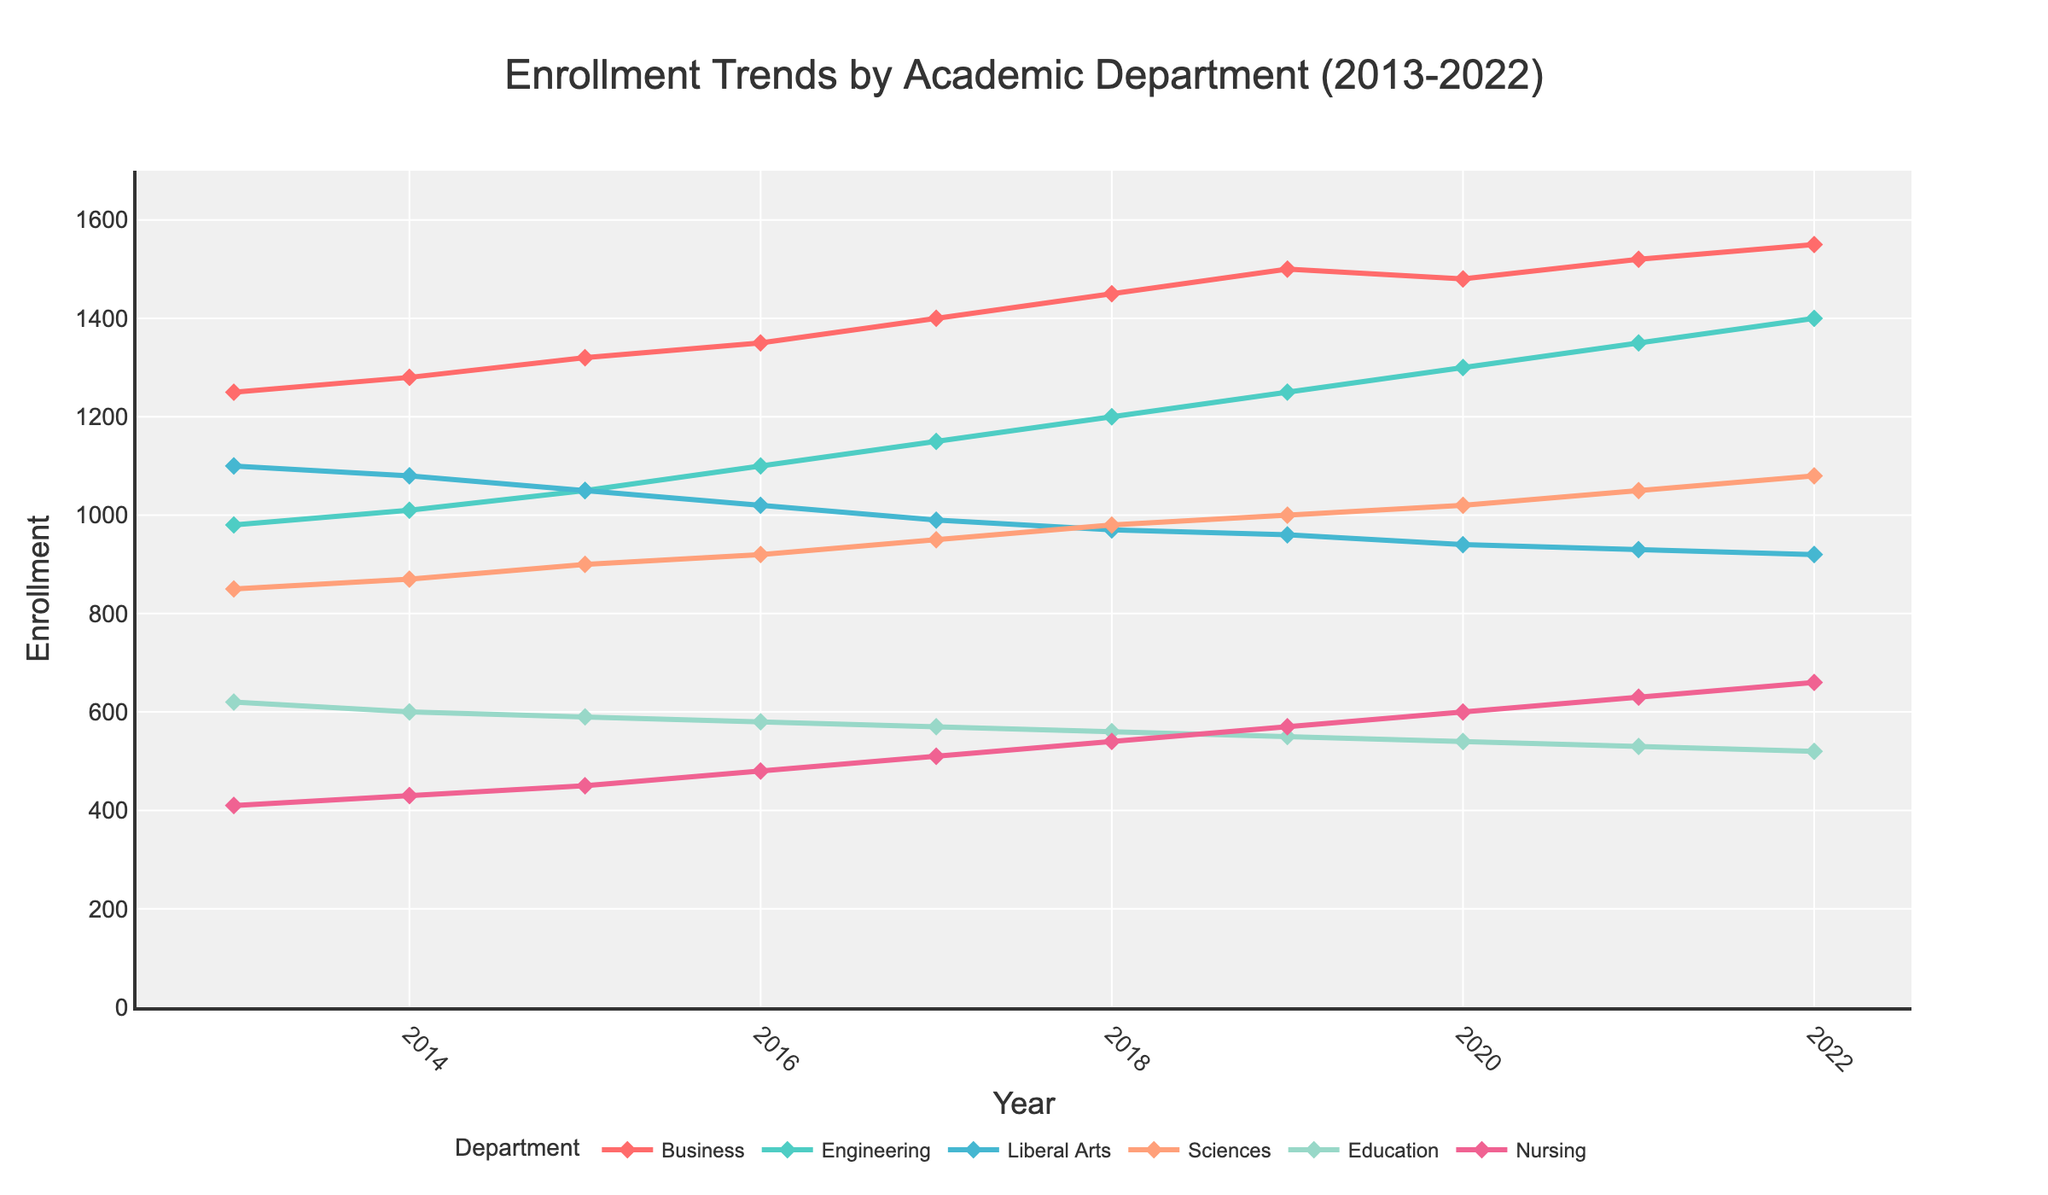Which department had the highest enrollment in 2022? To determine this, we look at the endpoints of all line plots for 2022. The Business department reaches the highest value on the y-axis.
Answer: Business How many total students were enrolled in 2017 across all departments? Sum the enrollment numbers of all departments for the year 2017: 1400 (Business) + 1150 (Engineering) + 990 (Liberal Arts) + 950 (Sciences) + 570 (Education) + 510 (Nursing). The total is 5570.
Answer: 5570 Which department experienced the greatest enrollment increase between 2013 and 2022? Calculate the difference in enrollment from 2013 to 2022 for each department and identify the largest difference. Business went from 1250 to 1550 (an increase of 300), the highest among all departments.
Answer: Business In what year did the Engineering department surpass 1000 enrollments? Look for the first year where the Engineering line plot crosses above 1000. That occurs in 2014.
Answer: 2014 What was the average enrollment for the Nursing department over the given period? Calculate the average of the Nursing enrollments from 2013 to 2022. Summing up the values: 410 + 430 + 450 + 480 + 510 + 540 + 570 + 600 + 630 + 660 = 5280. Dividing by 10 years gives an average of 528.
Answer: 528 Which department's enrollment decreased between 2019 and 2020? Compare the enrollment figures of each department from 2019 to 2020. The Business department shows a decrease from 1500 to 1480.
Answer: Business In 2016, how did the enrollment in Liberal Arts compare to that in Education? Look at the 2016 data points for both departments: Liberal Arts had 1020 and Education had 580. By comparing the two, Liberal Arts had a higher enrollment.
Answer: Liberal Arts What was the overall trend for the Sciences department from 2013 to 2022? Assess the plot for the Sciences department over the time span. The trend shows a consistent increase from 850 in 2013 to 1080 in 2022.
Answer: Increasing By how much did the Education department enrollment change from 2017 to 2022? Subtract the 2017 value from the 2022 value for Education: 570 - 520 = 50. The enrollment decreased by 50.
Answer: Decreased by 50 What is the range of enrollments for the Engineering department from 2013 to 2022? Identify the minimum and maximum enrollments for Engineering: the minimum is 980 in 2013 and the maximum is 1400 in 2022. The range is 1400 - 980 = 420.
Answer: 420 